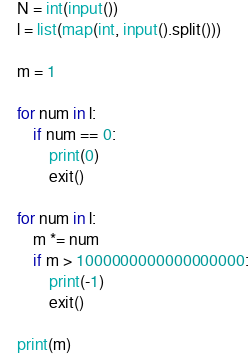Convert code to text. <code><loc_0><loc_0><loc_500><loc_500><_Python_>N = int(input())
l = list(map(int, input().split()))

m = 1

for num in l:
    if num == 0:
        print(0)
        exit()

for num in l:
    m *= num
    if m > 1000000000000000000:
        print(-1)
        exit()

print(m)
</code> 